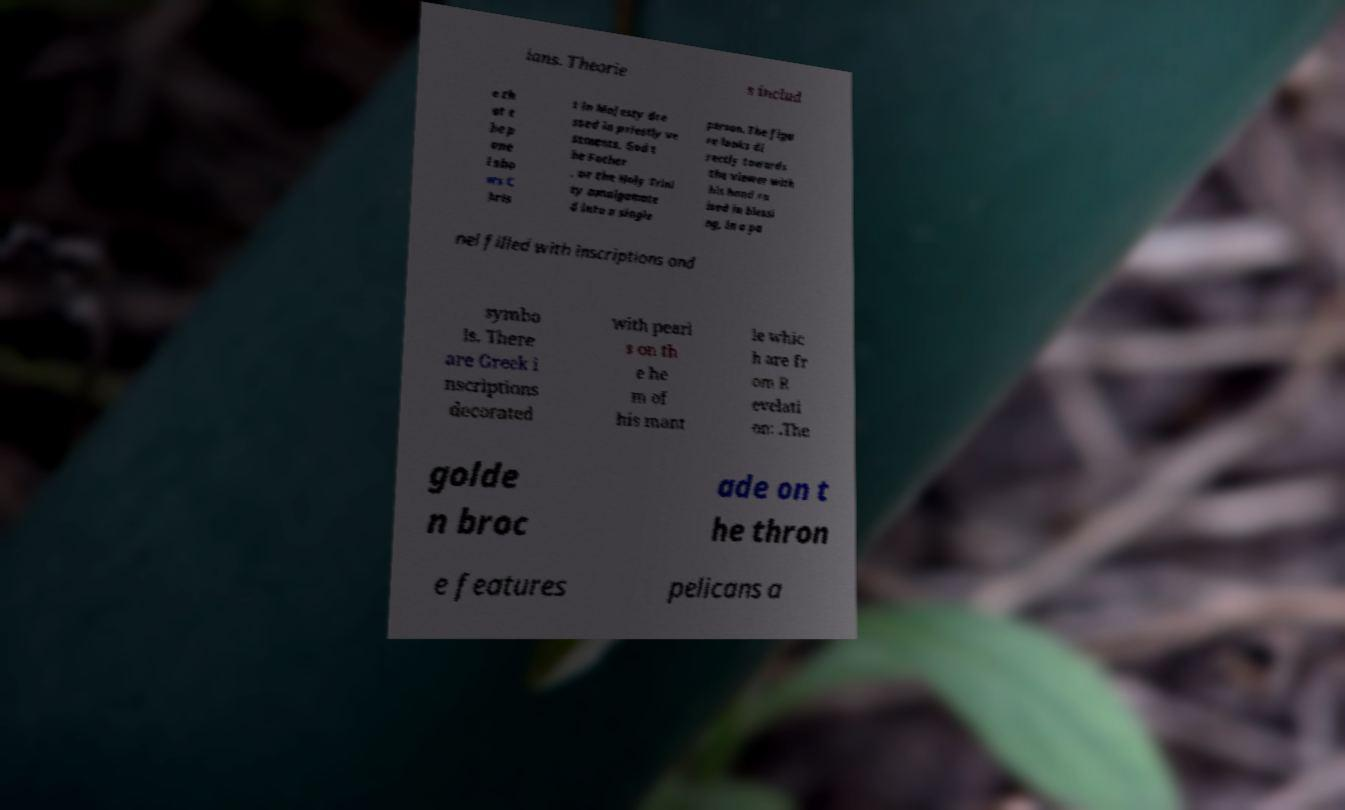Please identify and transcribe the text found in this image. ians. Theorie s includ e th at t he p ane l sho ws C hris t in Majesty dre ssed in priestly ve stments, God t he Father , or the Holy Trini ty amalgamate d into a single person. The figu re looks di rectly towards the viewer with his hand ra ised in blessi ng, in a pa nel filled with inscriptions and symbo ls. There are Greek i nscriptions decorated with pearl s on th e he m of his mant le whic h are fr om R evelati on: .The golde n broc ade on t he thron e features pelicans a 